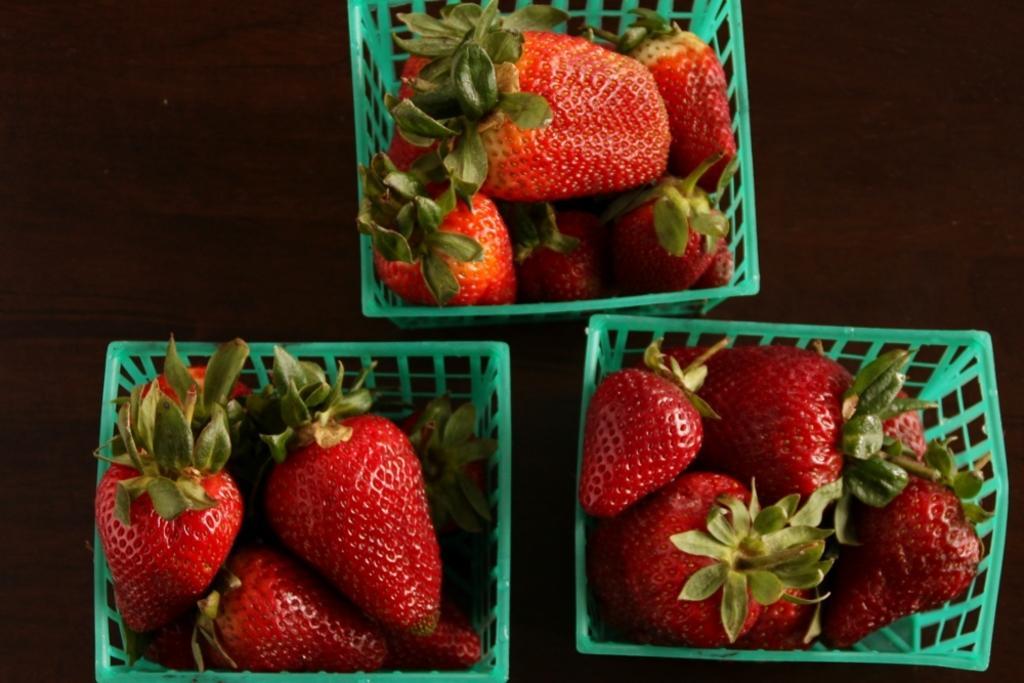In one or two sentences, can you explain what this image depicts? In this image, we can see some fruits in green colored objects are placed on the wooden surface. 